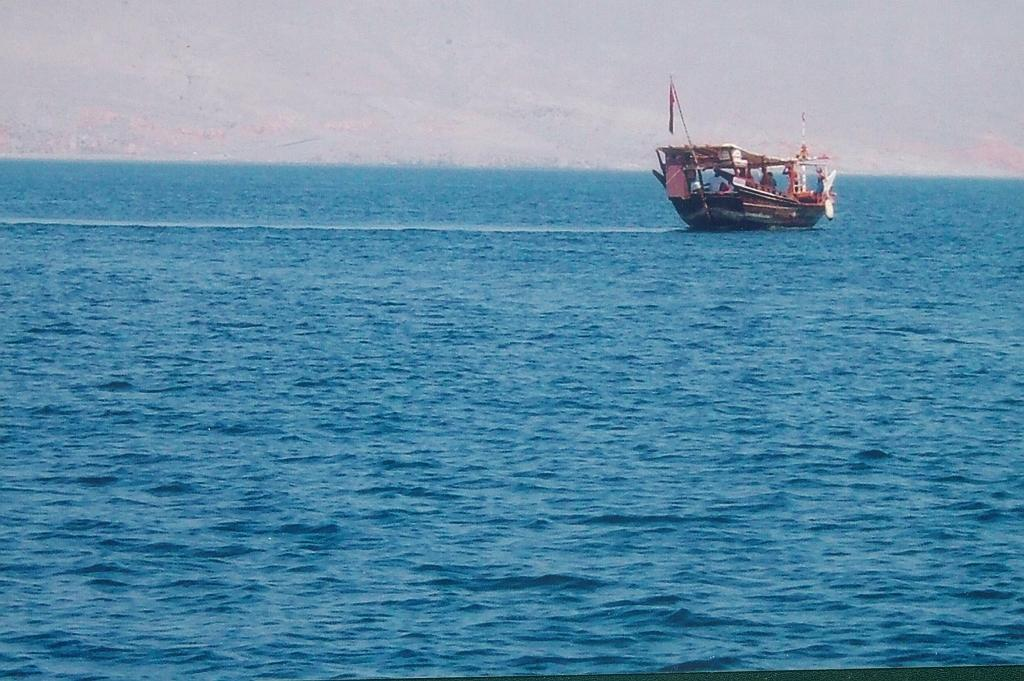What is the main subject of the image? The main subject of the image is a boat. Can you describe the appearance of the boat? The boat has different colors. What other object can be seen in the image? There is a flag in the image. How would you describe the water in the image? The water is blue in color. What is the color of the background in the image? The background is white in color. How many bears can be seen playing in the cemetery in the image? There are no bears or cemeteries present in the image; it features a boat on water with a flag. 